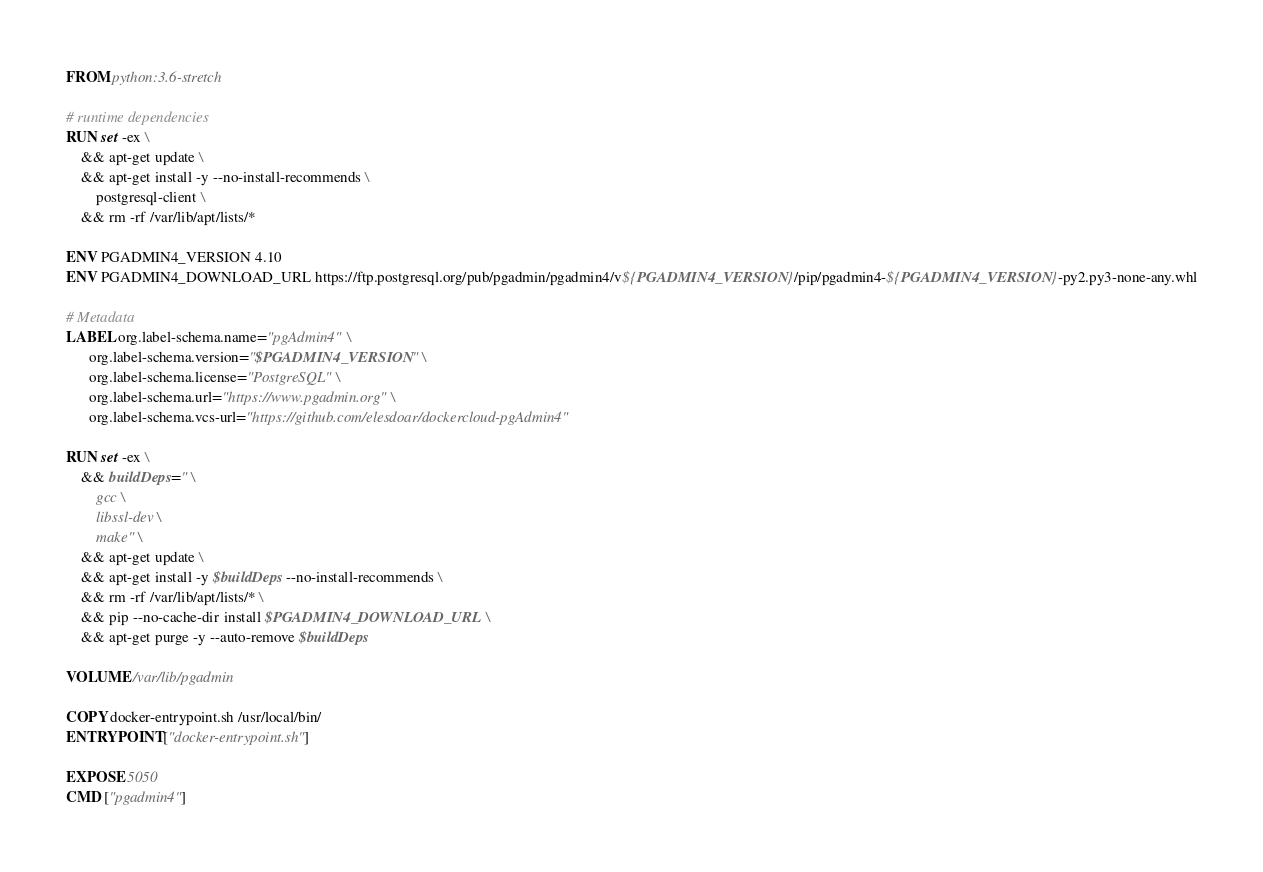Convert code to text. <code><loc_0><loc_0><loc_500><loc_500><_Dockerfile_>FROM python:3.6-stretch

# runtime dependencies
RUN set -ex \
	&& apt-get update \
	&& apt-get install -y --no-install-recommends \
		postgresql-client \
	&& rm -rf /var/lib/apt/lists/*

ENV PGADMIN4_VERSION 4.10
ENV PGADMIN4_DOWNLOAD_URL https://ftp.postgresql.org/pub/pgadmin/pgadmin4/v${PGADMIN4_VERSION}/pip/pgadmin4-${PGADMIN4_VERSION}-py2.py3-none-any.whl

# Metadata
LABEL org.label-schema.name="pgAdmin4" \
      org.label-schema.version="$PGADMIN4_VERSION" \
      org.label-schema.license="PostgreSQL" \
      org.label-schema.url="https://www.pgadmin.org" \
      org.label-schema.vcs-url="https://github.com/elesdoar/dockercloud-pgAdmin4"

RUN set -ex \
	&& buildDeps=" \
		gcc \
		libssl-dev \
		make" \
	&& apt-get update \
	&& apt-get install -y $buildDeps --no-install-recommends \
	&& rm -rf /var/lib/apt/lists/* \
	&& pip --no-cache-dir install $PGADMIN4_DOWNLOAD_URL \
	&& apt-get purge -y --auto-remove $buildDeps

VOLUME /var/lib/pgadmin

COPY docker-entrypoint.sh /usr/local/bin/
ENTRYPOINT ["docker-entrypoint.sh"]

EXPOSE 5050
CMD ["pgadmin4"]
</code> 